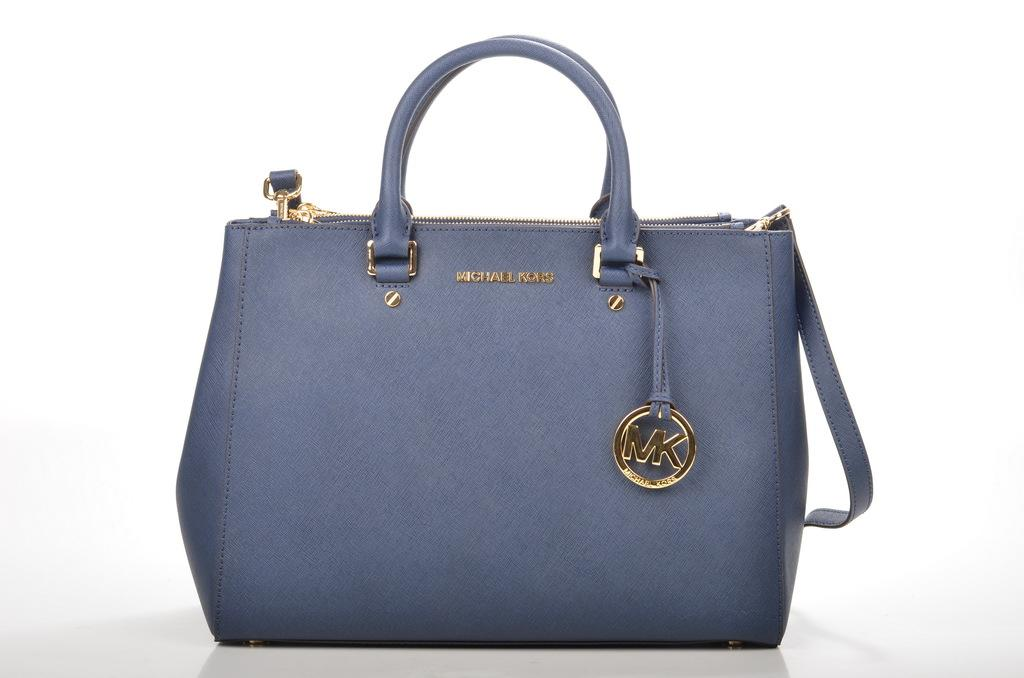What object is in the middle of the picture? There is a handbag in the middle of the picture. How is the handbag described in the image? The handbag is described as beautiful. Is there any text present on the handbag? Yes, there is text written on the handbag. Where is the doll holding the umbrella in the image? There is no doll or umbrella present in the image. What sound does the chicken make in the image? There is no chicken present in the image, so it cannot make any sound. 